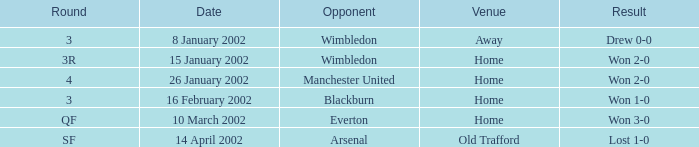What is the Date with a Opponent with wimbledon, and a Result of won 2-0? 15 January 2002. 